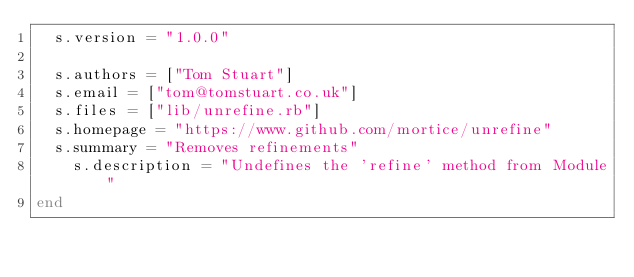<code> <loc_0><loc_0><loc_500><loc_500><_Ruby_>  s.version = "1.0.0"

  s.authors = ["Tom Stuart"]
  s.email = ["tom@tomstuart.co.uk"]
  s.files = ["lib/unrefine.rb"]
  s.homepage = "https://www.github.com/mortice/unrefine"
  s.summary = "Removes refinements"
	s.description = "Undefines the 'refine' method from Module"
end
</code> 